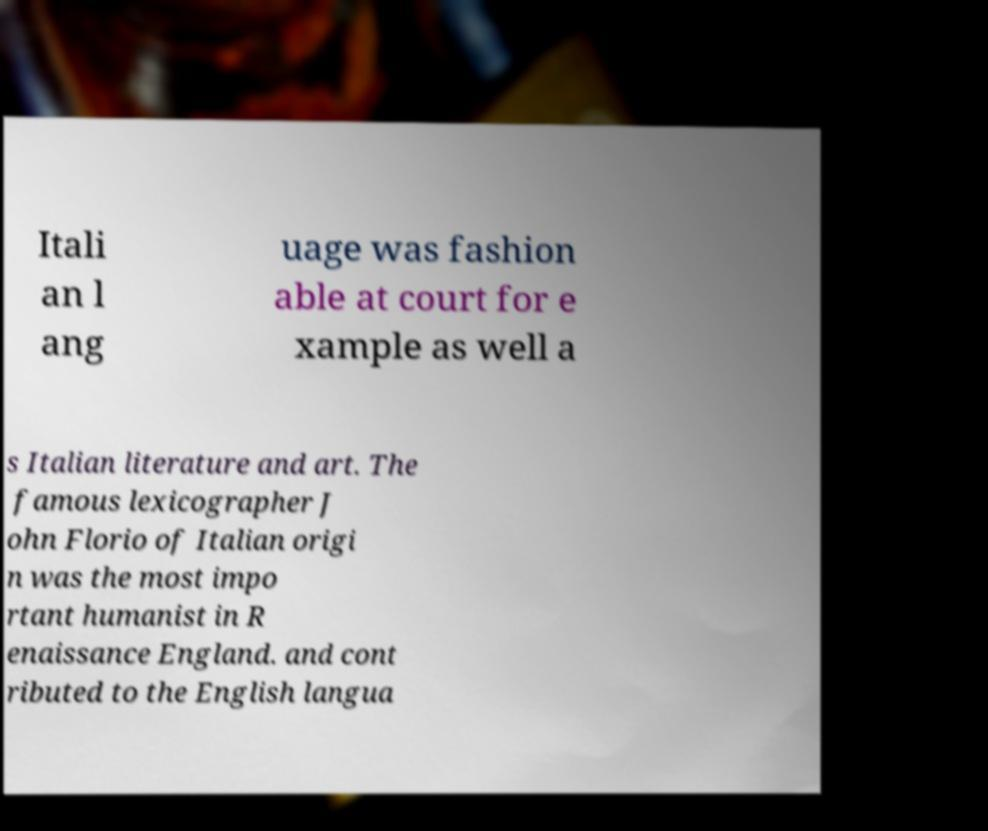For documentation purposes, I need the text within this image transcribed. Could you provide that? Itali an l ang uage was fashion able at court for e xample as well a s Italian literature and art. The famous lexicographer J ohn Florio of Italian origi n was the most impo rtant humanist in R enaissance England. and cont ributed to the English langua 